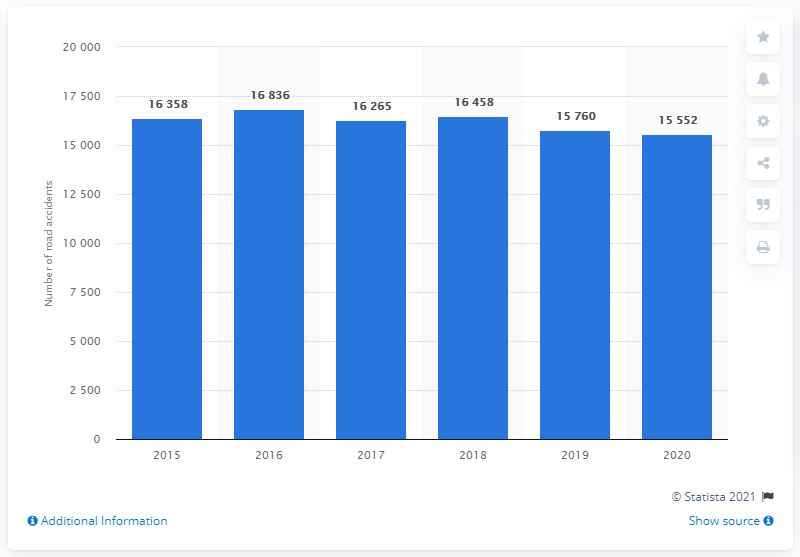Draw attention to some important aspects in this diagram. In 2020, there were 15,552 road accidents involving drink-driving drivers in Russia. In the previous year, there were 15,760 road accidents involving drink-driving drivers in Russia. 